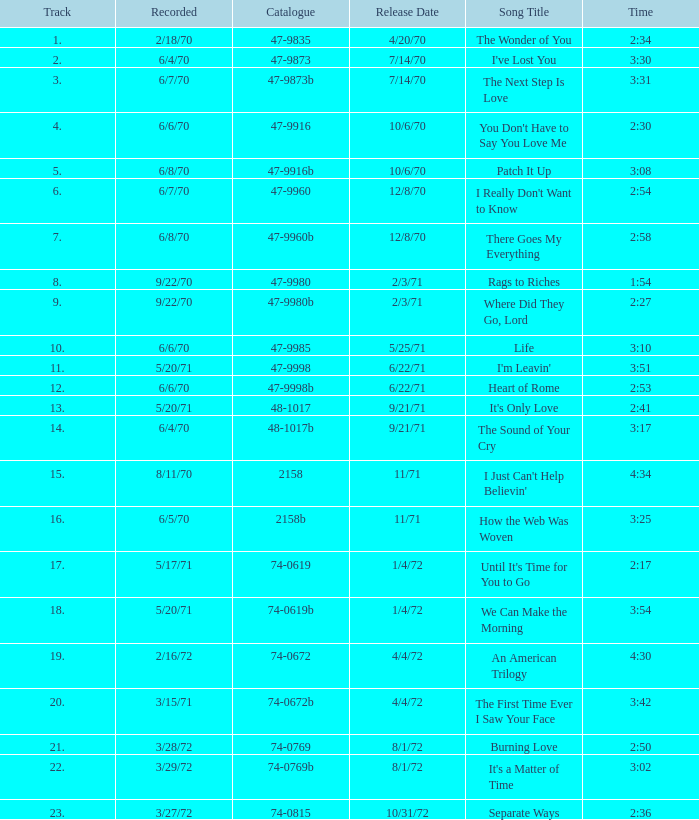What is the index number for the track that is 3:17 and was launched on 9/21/71? 48-1017b. 